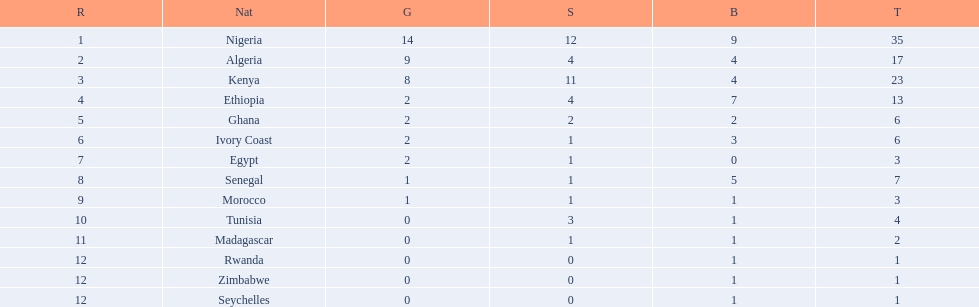Which nations competed in the 1989 african championships in athletics? Nigeria, Algeria, Kenya, Ethiopia, Ghana, Ivory Coast, Egypt, Senegal, Morocco, Tunisia, Madagascar, Rwanda, Zimbabwe, Seychelles. Of these nations, which earned 0 bronze medals? Egypt. 